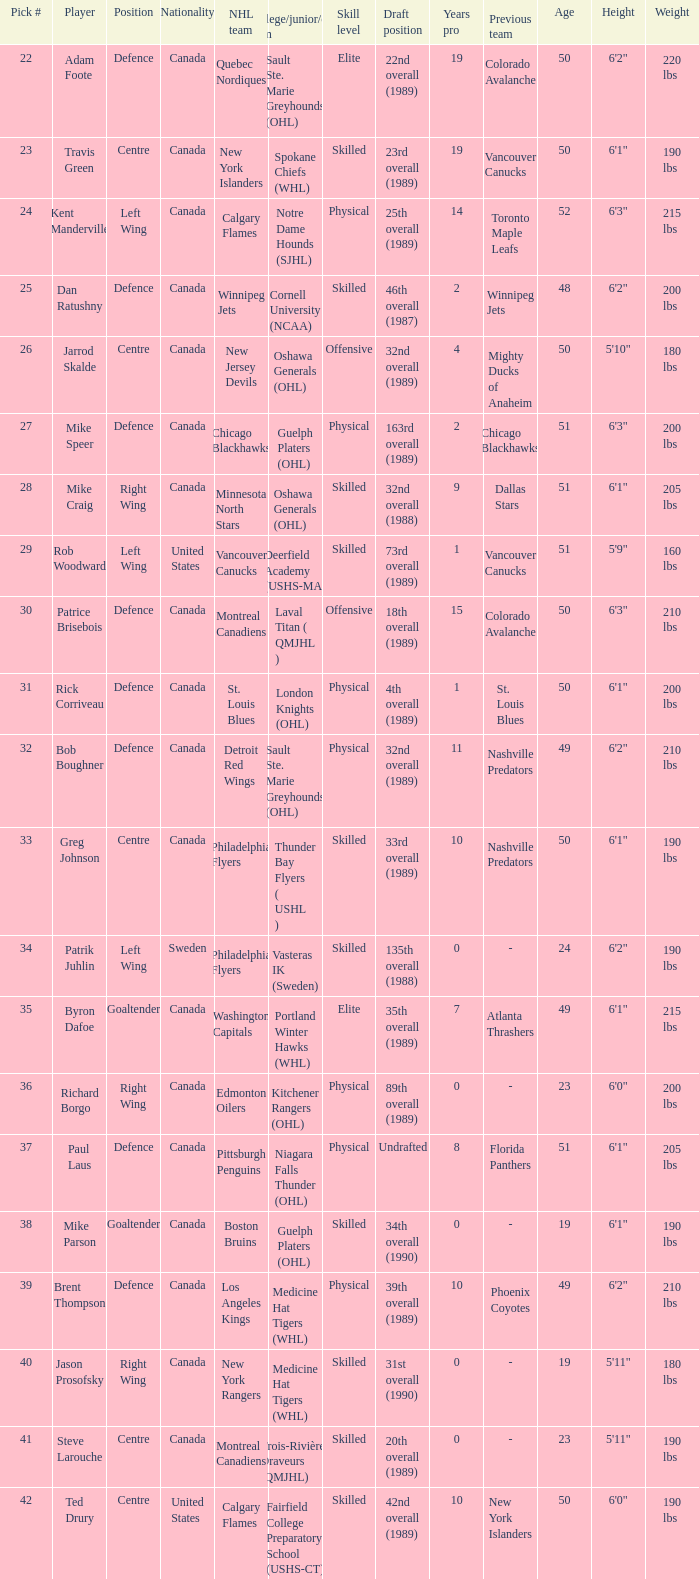What nhl team drafted richard borgo? Edmonton Oilers. Help me parse the entirety of this table. {'header': ['Pick #', 'Player', 'Position', 'Nationality', 'NHL team', 'College/junior/club team', 'Skill level', 'Draft position', 'Years pro', 'Previous team', 'Age', 'Height', 'Weight'], 'rows': [['22', 'Adam Foote', 'Defence', 'Canada', 'Quebec Nordiques', 'Sault Ste. Marie Greyhounds (OHL)', 'Elite', '22nd overall (1989)', '19', 'Colorado Avalanche', '50', '6\'2"', '220 lbs'], ['23', 'Travis Green', 'Centre', 'Canada', 'New York Islanders', 'Spokane Chiefs (WHL)', 'Skilled', '23rd overall (1989)', '19', 'Vancouver Canucks', '50', '6\'1"', '190 lbs'], ['24', 'Kent Manderville', 'Left Wing', 'Canada', 'Calgary Flames', 'Notre Dame Hounds (SJHL)', 'Physical', '25th overall (1989)', '14', 'Toronto Maple Leafs', '52', '6\'3"', '215 lbs'], ['25', 'Dan Ratushny', 'Defence', 'Canada', 'Winnipeg Jets', 'Cornell University (NCAA)', 'Skilled', '46th overall (1987)', '2', 'Winnipeg Jets', '48', '6\'2"', '200 lbs'], ['26', 'Jarrod Skalde', 'Centre', 'Canada', 'New Jersey Devils', 'Oshawa Generals (OHL)', 'Offensive', '32nd overall (1989)', '4', 'Mighty Ducks of Anaheim', '50', '5\'10"', '180 lbs'], ['27', 'Mike Speer', 'Defence', 'Canada', 'Chicago Blackhawks', 'Guelph Platers (OHL)', 'Physical', '163rd overall (1989)', '2', 'Chicago Blackhawks', '51', '6\'3"', '200 lbs'], ['28', 'Mike Craig', 'Right Wing', 'Canada', 'Minnesota North Stars', 'Oshawa Generals (OHL)', 'Skilled', '32nd overall (1988)', '9', 'Dallas Stars', '51', '6\'1"', '205 lbs'], ['29', 'Rob Woodward', 'Left Wing', 'United States', 'Vancouver Canucks', 'Deerfield Academy (USHS-MA)', 'Skilled', '73rd overall (1989)', '1', 'Vancouver Canucks', '51', '5\'9"', '160 lbs'], ['30', 'Patrice Brisebois', 'Defence', 'Canada', 'Montreal Canadiens', 'Laval Titan ( QMJHL )', 'Offensive', '18th overall (1989)', '15', 'Colorado Avalanche', '50', '6\'3"', '210 lbs'], ['31', 'Rick Corriveau', 'Defence', 'Canada', 'St. Louis Blues', 'London Knights (OHL)', 'Physical', '4th overall (1989)', '1', 'St. Louis Blues', '50', '6\'1"', '200 lbs'], ['32', 'Bob Boughner', 'Defence', 'Canada', 'Detroit Red Wings', 'Sault Ste. Marie Greyhounds (OHL)', 'Physical', '32nd overall (1989)', '11', 'Nashville Predators', '49', '6\'2"', '210 lbs'], ['33', 'Greg Johnson', 'Centre', 'Canada', 'Philadelphia Flyers', 'Thunder Bay Flyers ( USHL )', 'Skilled', '33rd overall (1989)', '10', 'Nashville Predators', '50', '6\'1"', '190 lbs'], ['34', 'Patrik Juhlin', 'Left Wing', 'Sweden', 'Philadelphia Flyers', 'Vasteras IK (Sweden)', 'Skilled', '135th overall (1988)', '0', '-', '24', '6\'2"', '190 lbs'], ['35', 'Byron Dafoe', 'Goaltender', 'Canada', 'Washington Capitals', 'Portland Winter Hawks (WHL)', 'Elite', '35th overall (1989)', '7', 'Atlanta Thrashers', '49', '6\'1"', '215 lbs'], ['36', 'Richard Borgo', 'Right Wing', 'Canada', 'Edmonton Oilers', 'Kitchener Rangers (OHL)', 'Physical', '89th overall (1989)', '0', '-', '23', '6\'0"', '200 lbs'], ['37', 'Paul Laus', 'Defence', 'Canada', 'Pittsburgh Penguins', 'Niagara Falls Thunder (OHL)', 'Physical', 'Undrafted', '8', 'Florida Panthers', '51', '6\'1"', '205 lbs'], ['38', 'Mike Parson', 'Goaltender', 'Canada', 'Boston Bruins', 'Guelph Platers (OHL)', 'Skilled', '34th overall (1990)', '0', '-', '19', '6\'1"', '190 lbs'], ['39', 'Brent Thompson', 'Defence', 'Canada', 'Los Angeles Kings', 'Medicine Hat Tigers (WHL)', 'Physical', '39th overall (1989)', '10', 'Phoenix Coyotes', '49', '6\'2"', '210 lbs'], ['40', 'Jason Prosofsky', 'Right Wing', 'Canada', 'New York Rangers', 'Medicine Hat Tigers (WHL)', 'Skilled', '31st overall (1990)', '0', '-', '19', '5\'11"', '180 lbs'], ['41', 'Steve Larouche', 'Centre', 'Canada', 'Montreal Canadiens', 'Trois-Rivières Draveurs (QMJHL)', 'Skilled', '20th overall (1989)', '0', '-', '23', '5\'11"', '190 lbs'], ['42', 'Ted Drury', 'Centre', 'United States', 'Calgary Flames', 'Fairfield College Preparatory School (USHS-CT)', 'Skilled', '42nd overall (1989)', '10', 'New York Islanders', '50', '6\'0"', '190 lbs']]} 